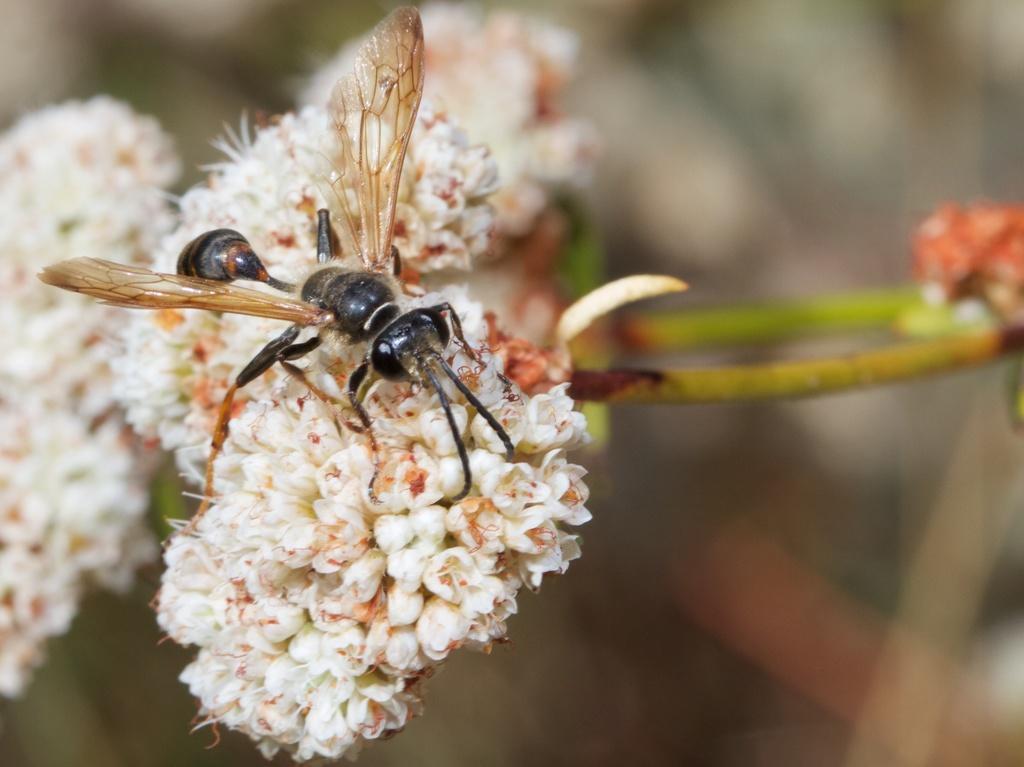How would you summarize this image in a sentence or two? In this image there are white color flowers. There is an insect. The image is blurry in the background. 